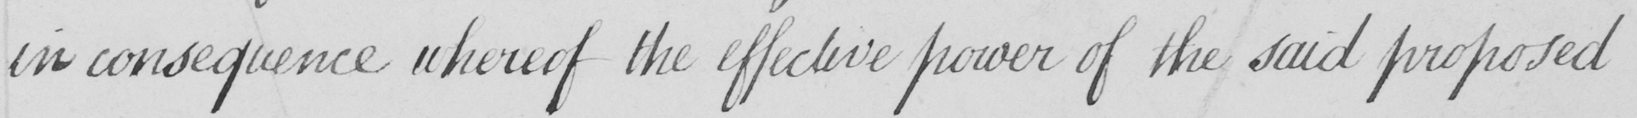Can you read and transcribe this handwriting? in consequence whereof the effective power of the said proposed 